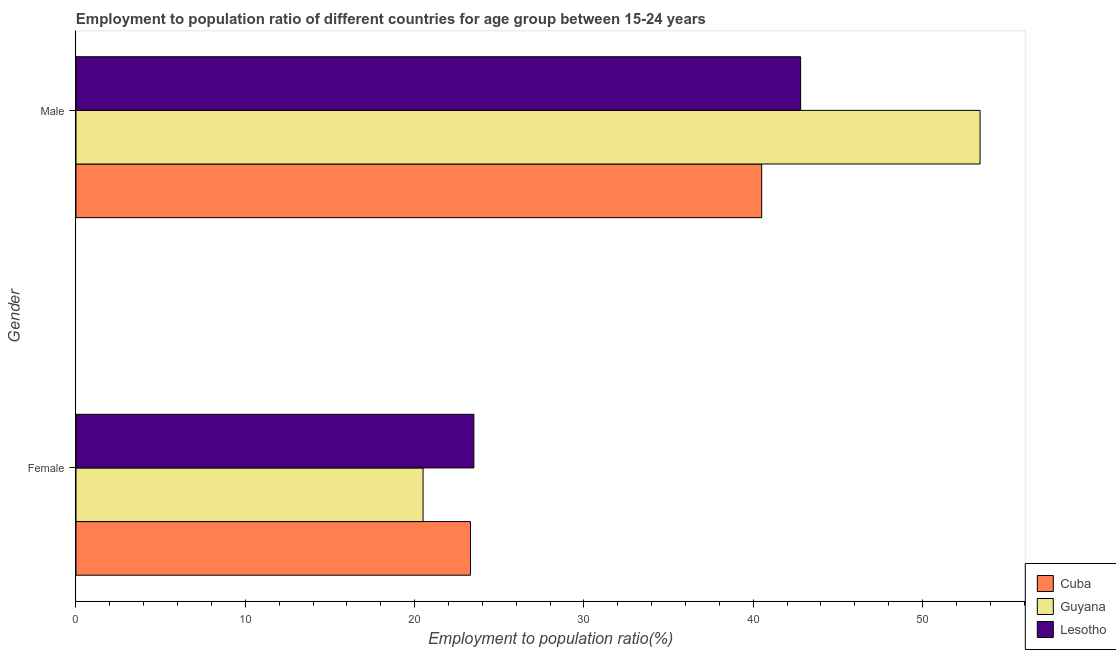How many different coloured bars are there?
Offer a terse response. 3. Are the number of bars per tick equal to the number of legend labels?
Offer a very short reply. Yes. What is the employment to population ratio(male) in Cuba?
Provide a short and direct response. 40.5. Across all countries, what is the maximum employment to population ratio(female)?
Ensure brevity in your answer.  23.5. In which country was the employment to population ratio(male) maximum?
Give a very brief answer. Guyana. In which country was the employment to population ratio(female) minimum?
Your answer should be very brief. Guyana. What is the total employment to population ratio(male) in the graph?
Offer a very short reply. 136.7. What is the difference between the employment to population ratio(female) in Lesotho and that in Cuba?
Ensure brevity in your answer.  0.2. What is the average employment to population ratio(male) per country?
Give a very brief answer. 45.57. What is the difference between the employment to population ratio(male) and employment to population ratio(female) in Guyana?
Your answer should be very brief. 32.9. What is the ratio of the employment to population ratio(female) in Lesotho to that in Guyana?
Offer a terse response. 1.15. What does the 2nd bar from the top in Male represents?
Give a very brief answer. Guyana. What does the 1st bar from the bottom in Female represents?
Offer a very short reply. Cuba. Are all the bars in the graph horizontal?
Offer a very short reply. Yes. What is the difference between two consecutive major ticks on the X-axis?
Offer a very short reply. 10. Does the graph contain any zero values?
Your response must be concise. No. Does the graph contain grids?
Provide a succinct answer. No. How many legend labels are there?
Offer a terse response. 3. What is the title of the graph?
Offer a terse response. Employment to population ratio of different countries for age group between 15-24 years. Does "Rwanda" appear as one of the legend labels in the graph?
Provide a succinct answer. No. What is the label or title of the X-axis?
Make the answer very short. Employment to population ratio(%). What is the Employment to population ratio(%) of Cuba in Female?
Offer a very short reply. 23.3. What is the Employment to population ratio(%) of Cuba in Male?
Ensure brevity in your answer.  40.5. What is the Employment to population ratio(%) of Guyana in Male?
Give a very brief answer. 53.4. What is the Employment to population ratio(%) of Lesotho in Male?
Keep it short and to the point. 42.8. Across all Gender, what is the maximum Employment to population ratio(%) of Cuba?
Ensure brevity in your answer.  40.5. Across all Gender, what is the maximum Employment to population ratio(%) in Guyana?
Your answer should be compact. 53.4. Across all Gender, what is the maximum Employment to population ratio(%) in Lesotho?
Your answer should be very brief. 42.8. Across all Gender, what is the minimum Employment to population ratio(%) in Cuba?
Offer a terse response. 23.3. Across all Gender, what is the minimum Employment to population ratio(%) in Lesotho?
Offer a terse response. 23.5. What is the total Employment to population ratio(%) in Cuba in the graph?
Provide a succinct answer. 63.8. What is the total Employment to population ratio(%) in Guyana in the graph?
Your answer should be very brief. 73.9. What is the total Employment to population ratio(%) of Lesotho in the graph?
Your answer should be compact. 66.3. What is the difference between the Employment to population ratio(%) of Cuba in Female and that in Male?
Your answer should be very brief. -17.2. What is the difference between the Employment to population ratio(%) in Guyana in Female and that in Male?
Provide a succinct answer. -32.9. What is the difference between the Employment to population ratio(%) of Lesotho in Female and that in Male?
Offer a very short reply. -19.3. What is the difference between the Employment to population ratio(%) in Cuba in Female and the Employment to population ratio(%) in Guyana in Male?
Provide a succinct answer. -30.1. What is the difference between the Employment to population ratio(%) of Cuba in Female and the Employment to population ratio(%) of Lesotho in Male?
Give a very brief answer. -19.5. What is the difference between the Employment to population ratio(%) in Guyana in Female and the Employment to population ratio(%) in Lesotho in Male?
Provide a short and direct response. -22.3. What is the average Employment to population ratio(%) of Cuba per Gender?
Ensure brevity in your answer.  31.9. What is the average Employment to population ratio(%) in Guyana per Gender?
Make the answer very short. 36.95. What is the average Employment to population ratio(%) in Lesotho per Gender?
Provide a short and direct response. 33.15. What is the difference between the Employment to population ratio(%) in Cuba and Employment to population ratio(%) in Lesotho in Female?
Offer a terse response. -0.2. What is the ratio of the Employment to population ratio(%) in Cuba in Female to that in Male?
Offer a terse response. 0.58. What is the ratio of the Employment to population ratio(%) of Guyana in Female to that in Male?
Your answer should be compact. 0.38. What is the ratio of the Employment to population ratio(%) in Lesotho in Female to that in Male?
Ensure brevity in your answer.  0.55. What is the difference between the highest and the second highest Employment to population ratio(%) in Cuba?
Offer a terse response. 17.2. What is the difference between the highest and the second highest Employment to population ratio(%) in Guyana?
Provide a succinct answer. 32.9. What is the difference between the highest and the second highest Employment to population ratio(%) of Lesotho?
Keep it short and to the point. 19.3. What is the difference between the highest and the lowest Employment to population ratio(%) of Guyana?
Provide a succinct answer. 32.9. What is the difference between the highest and the lowest Employment to population ratio(%) in Lesotho?
Provide a succinct answer. 19.3. 